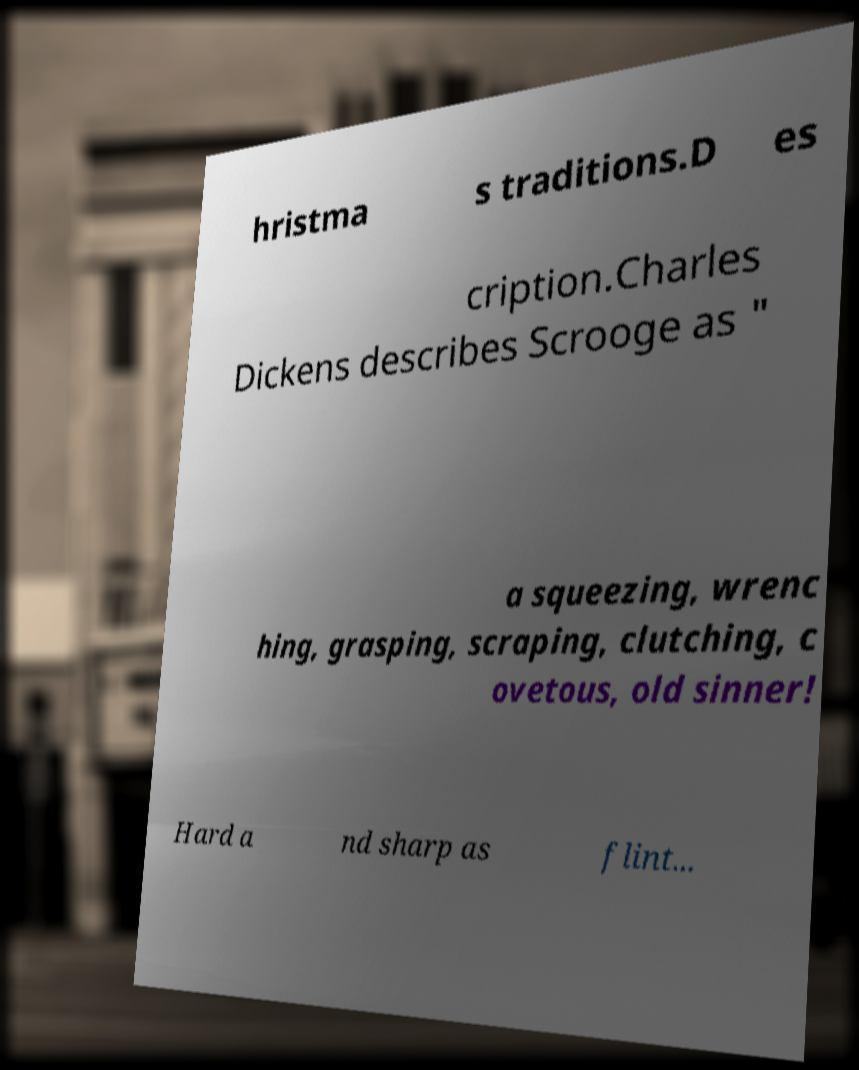There's text embedded in this image that I need extracted. Can you transcribe it verbatim? hristma s traditions.D es cription.Charles Dickens describes Scrooge as " a squeezing, wrenc hing, grasping, scraping, clutching, c ovetous, old sinner! Hard a nd sharp as flint... 